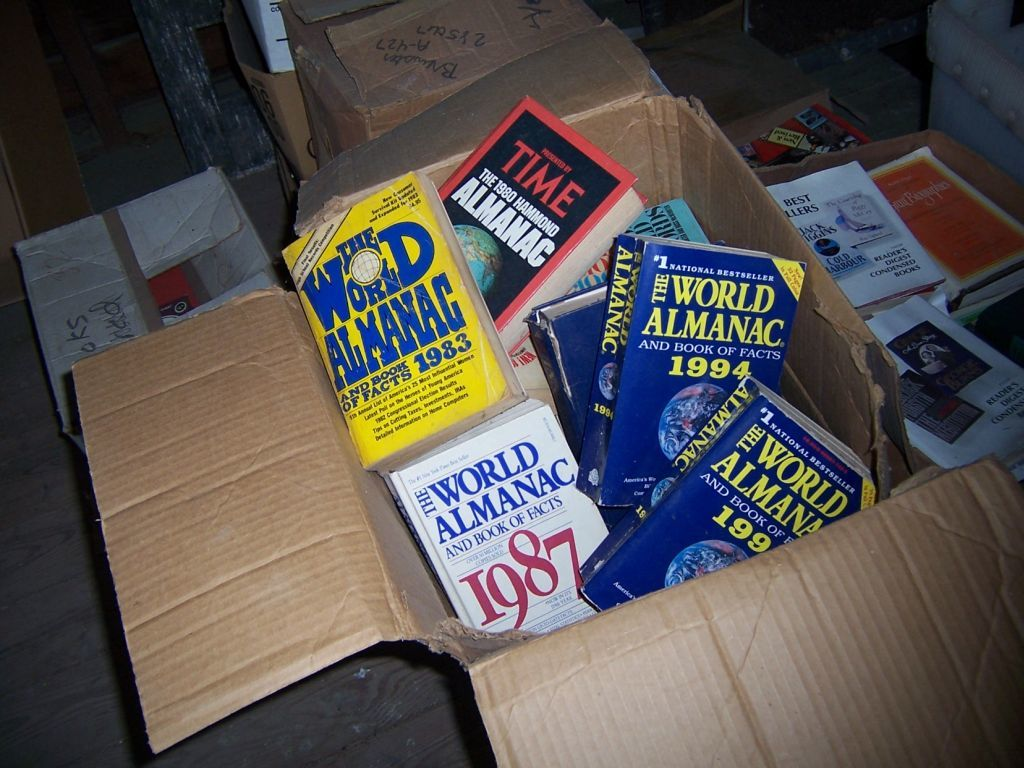Describe the physical condition of the books and what it suggests about their usage. The books appear well-used with visible wear and tear on the covers and spines, which suggests they were frequently referenced and possibly cherished by their owner for personal or academic purposes. What might be the significance of storing these books in a cardboard box? Storing the books in a cardboard box could indicate a temporary solution, perhaps due to moving or lack of space, or it might reflect a casual storage method that prioritizes accessibility over preservation. 